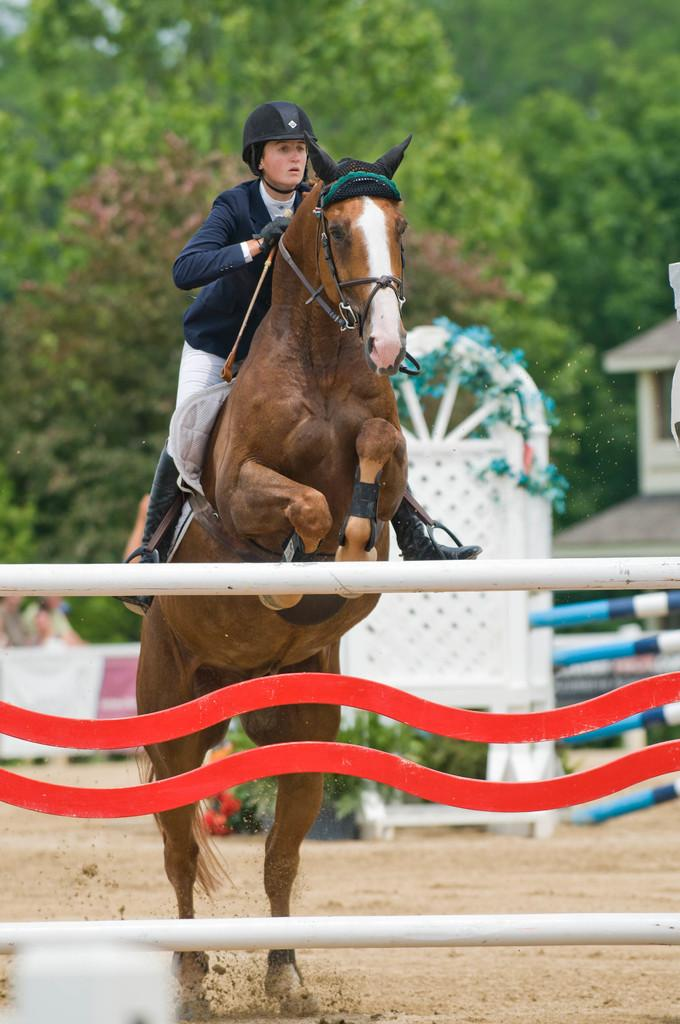What animal is present in the image? There is a horse in the image. Who is on the horse? A man is sitting on the horse. Can you describe the background of the image? The background of the image is blurry. What type of feast is being prepared in the background of the image? There is no feast or any indication of food preparation in the image; it only features a horse and a man sitting on it. 